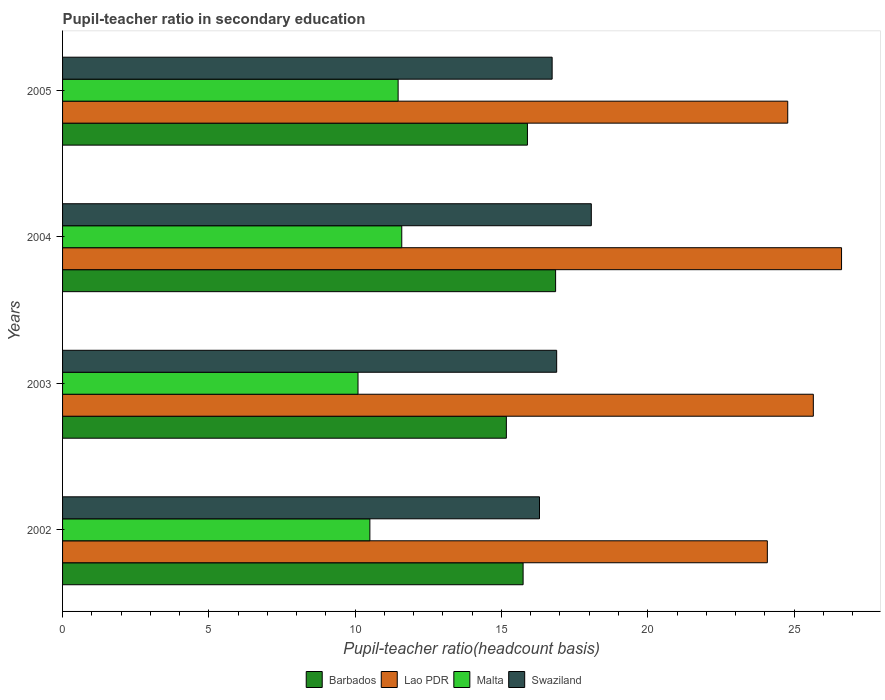Are the number of bars per tick equal to the number of legend labels?
Make the answer very short. Yes. What is the label of the 2nd group of bars from the top?
Provide a short and direct response. 2004. What is the pupil-teacher ratio in secondary education in Lao PDR in 2004?
Give a very brief answer. 26.62. Across all years, what is the maximum pupil-teacher ratio in secondary education in Lao PDR?
Keep it short and to the point. 26.62. Across all years, what is the minimum pupil-teacher ratio in secondary education in Lao PDR?
Keep it short and to the point. 24.09. What is the total pupil-teacher ratio in secondary education in Swaziland in the graph?
Make the answer very short. 67.99. What is the difference between the pupil-teacher ratio in secondary education in Barbados in 2003 and that in 2005?
Make the answer very short. -0.72. What is the difference between the pupil-teacher ratio in secondary education in Barbados in 2005 and the pupil-teacher ratio in secondary education in Malta in 2003?
Make the answer very short. 5.79. What is the average pupil-teacher ratio in secondary education in Lao PDR per year?
Your answer should be compact. 25.29. In the year 2004, what is the difference between the pupil-teacher ratio in secondary education in Barbados and pupil-teacher ratio in secondary education in Malta?
Provide a short and direct response. 5.26. In how many years, is the pupil-teacher ratio in secondary education in Swaziland greater than 20 ?
Make the answer very short. 0. What is the ratio of the pupil-teacher ratio in secondary education in Malta in 2003 to that in 2004?
Provide a short and direct response. 0.87. Is the pupil-teacher ratio in secondary education in Swaziland in 2003 less than that in 2004?
Provide a succinct answer. Yes. Is the difference between the pupil-teacher ratio in secondary education in Barbados in 2004 and 2005 greater than the difference between the pupil-teacher ratio in secondary education in Malta in 2004 and 2005?
Your answer should be compact. Yes. What is the difference between the highest and the second highest pupil-teacher ratio in secondary education in Swaziland?
Give a very brief answer. 1.18. What is the difference between the highest and the lowest pupil-teacher ratio in secondary education in Lao PDR?
Provide a short and direct response. 2.54. Is it the case that in every year, the sum of the pupil-teacher ratio in secondary education in Lao PDR and pupil-teacher ratio in secondary education in Malta is greater than the sum of pupil-teacher ratio in secondary education in Swaziland and pupil-teacher ratio in secondary education in Barbados?
Give a very brief answer. Yes. What does the 4th bar from the top in 2005 represents?
Make the answer very short. Barbados. What does the 1st bar from the bottom in 2004 represents?
Ensure brevity in your answer.  Barbados. Is it the case that in every year, the sum of the pupil-teacher ratio in secondary education in Barbados and pupil-teacher ratio in secondary education in Lao PDR is greater than the pupil-teacher ratio in secondary education in Swaziland?
Your response must be concise. Yes. Are all the bars in the graph horizontal?
Provide a short and direct response. Yes. How many years are there in the graph?
Make the answer very short. 4. Does the graph contain any zero values?
Provide a succinct answer. No. Does the graph contain grids?
Provide a succinct answer. No. How many legend labels are there?
Your answer should be very brief. 4. How are the legend labels stacked?
Provide a short and direct response. Horizontal. What is the title of the graph?
Ensure brevity in your answer.  Pupil-teacher ratio in secondary education. What is the label or title of the X-axis?
Offer a terse response. Pupil-teacher ratio(headcount basis). What is the Pupil-teacher ratio(headcount basis) in Barbados in 2002?
Provide a short and direct response. 15.74. What is the Pupil-teacher ratio(headcount basis) of Lao PDR in 2002?
Your answer should be very brief. 24.09. What is the Pupil-teacher ratio(headcount basis) of Malta in 2002?
Give a very brief answer. 10.5. What is the Pupil-teacher ratio(headcount basis) in Swaziland in 2002?
Provide a short and direct response. 16.3. What is the Pupil-teacher ratio(headcount basis) of Barbados in 2003?
Offer a very short reply. 15.17. What is the Pupil-teacher ratio(headcount basis) of Lao PDR in 2003?
Your answer should be very brief. 25.66. What is the Pupil-teacher ratio(headcount basis) of Malta in 2003?
Ensure brevity in your answer.  10.1. What is the Pupil-teacher ratio(headcount basis) in Swaziland in 2003?
Keep it short and to the point. 16.89. What is the Pupil-teacher ratio(headcount basis) of Barbados in 2004?
Keep it short and to the point. 16.85. What is the Pupil-teacher ratio(headcount basis) in Lao PDR in 2004?
Ensure brevity in your answer.  26.62. What is the Pupil-teacher ratio(headcount basis) of Malta in 2004?
Offer a very short reply. 11.59. What is the Pupil-teacher ratio(headcount basis) of Swaziland in 2004?
Ensure brevity in your answer.  18.07. What is the Pupil-teacher ratio(headcount basis) in Barbados in 2005?
Offer a terse response. 15.89. What is the Pupil-teacher ratio(headcount basis) of Lao PDR in 2005?
Your response must be concise. 24.78. What is the Pupil-teacher ratio(headcount basis) in Malta in 2005?
Keep it short and to the point. 11.47. What is the Pupil-teacher ratio(headcount basis) of Swaziland in 2005?
Make the answer very short. 16.73. Across all years, what is the maximum Pupil-teacher ratio(headcount basis) of Barbados?
Your response must be concise. 16.85. Across all years, what is the maximum Pupil-teacher ratio(headcount basis) in Lao PDR?
Give a very brief answer. 26.62. Across all years, what is the maximum Pupil-teacher ratio(headcount basis) in Malta?
Offer a terse response. 11.59. Across all years, what is the maximum Pupil-teacher ratio(headcount basis) in Swaziland?
Your answer should be compact. 18.07. Across all years, what is the minimum Pupil-teacher ratio(headcount basis) of Barbados?
Provide a short and direct response. 15.17. Across all years, what is the minimum Pupil-teacher ratio(headcount basis) in Lao PDR?
Keep it short and to the point. 24.09. Across all years, what is the minimum Pupil-teacher ratio(headcount basis) of Malta?
Offer a terse response. 10.1. Across all years, what is the minimum Pupil-teacher ratio(headcount basis) in Swaziland?
Make the answer very short. 16.3. What is the total Pupil-teacher ratio(headcount basis) of Barbados in the graph?
Your response must be concise. 63.65. What is the total Pupil-teacher ratio(headcount basis) in Lao PDR in the graph?
Provide a short and direct response. 101.16. What is the total Pupil-teacher ratio(headcount basis) in Malta in the graph?
Offer a very short reply. 43.66. What is the total Pupil-teacher ratio(headcount basis) in Swaziland in the graph?
Keep it short and to the point. 67.99. What is the difference between the Pupil-teacher ratio(headcount basis) in Barbados in 2002 and that in 2003?
Your answer should be very brief. 0.57. What is the difference between the Pupil-teacher ratio(headcount basis) in Lao PDR in 2002 and that in 2003?
Keep it short and to the point. -1.57. What is the difference between the Pupil-teacher ratio(headcount basis) of Malta in 2002 and that in 2003?
Offer a very short reply. 0.41. What is the difference between the Pupil-teacher ratio(headcount basis) of Swaziland in 2002 and that in 2003?
Your response must be concise. -0.59. What is the difference between the Pupil-teacher ratio(headcount basis) in Barbados in 2002 and that in 2004?
Offer a very short reply. -1.11. What is the difference between the Pupil-teacher ratio(headcount basis) in Lao PDR in 2002 and that in 2004?
Provide a succinct answer. -2.54. What is the difference between the Pupil-teacher ratio(headcount basis) of Malta in 2002 and that in 2004?
Give a very brief answer. -1.09. What is the difference between the Pupil-teacher ratio(headcount basis) of Swaziland in 2002 and that in 2004?
Your response must be concise. -1.77. What is the difference between the Pupil-teacher ratio(headcount basis) in Barbados in 2002 and that in 2005?
Ensure brevity in your answer.  -0.15. What is the difference between the Pupil-teacher ratio(headcount basis) in Lao PDR in 2002 and that in 2005?
Provide a succinct answer. -0.7. What is the difference between the Pupil-teacher ratio(headcount basis) in Malta in 2002 and that in 2005?
Ensure brevity in your answer.  -0.97. What is the difference between the Pupil-teacher ratio(headcount basis) of Swaziland in 2002 and that in 2005?
Ensure brevity in your answer.  -0.43. What is the difference between the Pupil-teacher ratio(headcount basis) in Barbados in 2003 and that in 2004?
Provide a short and direct response. -1.68. What is the difference between the Pupil-teacher ratio(headcount basis) of Lao PDR in 2003 and that in 2004?
Ensure brevity in your answer.  -0.96. What is the difference between the Pupil-teacher ratio(headcount basis) of Malta in 2003 and that in 2004?
Keep it short and to the point. -1.5. What is the difference between the Pupil-teacher ratio(headcount basis) of Swaziland in 2003 and that in 2004?
Keep it short and to the point. -1.18. What is the difference between the Pupil-teacher ratio(headcount basis) of Barbados in 2003 and that in 2005?
Ensure brevity in your answer.  -0.72. What is the difference between the Pupil-teacher ratio(headcount basis) of Lao PDR in 2003 and that in 2005?
Give a very brief answer. 0.88. What is the difference between the Pupil-teacher ratio(headcount basis) in Malta in 2003 and that in 2005?
Keep it short and to the point. -1.37. What is the difference between the Pupil-teacher ratio(headcount basis) in Swaziland in 2003 and that in 2005?
Provide a succinct answer. 0.15. What is the difference between the Pupil-teacher ratio(headcount basis) of Barbados in 2004 and that in 2005?
Your answer should be very brief. 0.96. What is the difference between the Pupil-teacher ratio(headcount basis) in Lao PDR in 2004 and that in 2005?
Your answer should be very brief. 1.84. What is the difference between the Pupil-teacher ratio(headcount basis) of Malta in 2004 and that in 2005?
Keep it short and to the point. 0.12. What is the difference between the Pupil-teacher ratio(headcount basis) in Swaziland in 2004 and that in 2005?
Give a very brief answer. 1.34. What is the difference between the Pupil-teacher ratio(headcount basis) of Barbados in 2002 and the Pupil-teacher ratio(headcount basis) of Lao PDR in 2003?
Your answer should be compact. -9.92. What is the difference between the Pupil-teacher ratio(headcount basis) of Barbados in 2002 and the Pupil-teacher ratio(headcount basis) of Malta in 2003?
Offer a very short reply. 5.64. What is the difference between the Pupil-teacher ratio(headcount basis) in Barbados in 2002 and the Pupil-teacher ratio(headcount basis) in Swaziland in 2003?
Your answer should be compact. -1.15. What is the difference between the Pupil-teacher ratio(headcount basis) in Lao PDR in 2002 and the Pupil-teacher ratio(headcount basis) in Malta in 2003?
Your response must be concise. 13.99. What is the difference between the Pupil-teacher ratio(headcount basis) of Lao PDR in 2002 and the Pupil-teacher ratio(headcount basis) of Swaziland in 2003?
Keep it short and to the point. 7.2. What is the difference between the Pupil-teacher ratio(headcount basis) in Malta in 2002 and the Pupil-teacher ratio(headcount basis) in Swaziland in 2003?
Give a very brief answer. -6.38. What is the difference between the Pupil-teacher ratio(headcount basis) in Barbados in 2002 and the Pupil-teacher ratio(headcount basis) in Lao PDR in 2004?
Provide a succinct answer. -10.88. What is the difference between the Pupil-teacher ratio(headcount basis) in Barbados in 2002 and the Pupil-teacher ratio(headcount basis) in Malta in 2004?
Give a very brief answer. 4.15. What is the difference between the Pupil-teacher ratio(headcount basis) in Barbados in 2002 and the Pupil-teacher ratio(headcount basis) in Swaziland in 2004?
Your response must be concise. -2.33. What is the difference between the Pupil-teacher ratio(headcount basis) in Lao PDR in 2002 and the Pupil-teacher ratio(headcount basis) in Malta in 2004?
Provide a short and direct response. 12.49. What is the difference between the Pupil-teacher ratio(headcount basis) of Lao PDR in 2002 and the Pupil-teacher ratio(headcount basis) of Swaziland in 2004?
Offer a very short reply. 6.02. What is the difference between the Pupil-teacher ratio(headcount basis) in Malta in 2002 and the Pupil-teacher ratio(headcount basis) in Swaziland in 2004?
Give a very brief answer. -7.57. What is the difference between the Pupil-teacher ratio(headcount basis) in Barbados in 2002 and the Pupil-teacher ratio(headcount basis) in Lao PDR in 2005?
Ensure brevity in your answer.  -9.04. What is the difference between the Pupil-teacher ratio(headcount basis) in Barbados in 2002 and the Pupil-teacher ratio(headcount basis) in Malta in 2005?
Your answer should be very brief. 4.27. What is the difference between the Pupil-teacher ratio(headcount basis) of Barbados in 2002 and the Pupil-teacher ratio(headcount basis) of Swaziland in 2005?
Offer a very short reply. -0.99. What is the difference between the Pupil-teacher ratio(headcount basis) in Lao PDR in 2002 and the Pupil-teacher ratio(headcount basis) in Malta in 2005?
Your answer should be compact. 12.62. What is the difference between the Pupil-teacher ratio(headcount basis) in Lao PDR in 2002 and the Pupil-teacher ratio(headcount basis) in Swaziland in 2005?
Offer a terse response. 7.36. What is the difference between the Pupil-teacher ratio(headcount basis) in Malta in 2002 and the Pupil-teacher ratio(headcount basis) in Swaziland in 2005?
Your answer should be very brief. -6.23. What is the difference between the Pupil-teacher ratio(headcount basis) in Barbados in 2003 and the Pupil-teacher ratio(headcount basis) in Lao PDR in 2004?
Your answer should be compact. -11.46. What is the difference between the Pupil-teacher ratio(headcount basis) of Barbados in 2003 and the Pupil-teacher ratio(headcount basis) of Malta in 2004?
Offer a terse response. 3.57. What is the difference between the Pupil-teacher ratio(headcount basis) of Barbados in 2003 and the Pupil-teacher ratio(headcount basis) of Swaziland in 2004?
Give a very brief answer. -2.9. What is the difference between the Pupil-teacher ratio(headcount basis) in Lao PDR in 2003 and the Pupil-teacher ratio(headcount basis) in Malta in 2004?
Your answer should be very brief. 14.07. What is the difference between the Pupil-teacher ratio(headcount basis) in Lao PDR in 2003 and the Pupil-teacher ratio(headcount basis) in Swaziland in 2004?
Give a very brief answer. 7.59. What is the difference between the Pupil-teacher ratio(headcount basis) in Malta in 2003 and the Pupil-teacher ratio(headcount basis) in Swaziland in 2004?
Provide a short and direct response. -7.97. What is the difference between the Pupil-teacher ratio(headcount basis) of Barbados in 2003 and the Pupil-teacher ratio(headcount basis) of Lao PDR in 2005?
Your answer should be very brief. -9.62. What is the difference between the Pupil-teacher ratio(headcount basis) in Barbados in 2003 and the Pupil-teacher ratio(headcount basis) in Malta in 2005?
Give a very brief answer. 3.7. What is the difference between the Pupil-teacher ratio(headcount basis) in Barbados in 2003 and the Pupil-teacher ratio(headcount basis) in Swaziland in 2005?
Offer a very short reply. -1.56. What is the difference between the Pupil-teacher ratio(headcount basis) in Lao PDR in 2003 and the Pupil-teacher ratio(headcount basis) in Malta in 2005?
Ensure brevity in your answer.  14.19. What is the difference between the Pupil-teacher ratio(headcount basis) in Lao PDR in 2003 and the Pupil-teacher ratio(headcount basis) in Swaziland in 2005?
Your answer should be compact. 8.93. What is the difference between the Pupil-teacher ratio(headcount basis) in Malta in 2003 and the Pupil-teacher ratio(headcount basis) in Swaziland in 2005?
Provide a succinct answer. -6.64. What is the difference between the Pupil-teacher ratio(headcount basis) of Barbados in 2004 and the Pupil-teacher ratio(headcount basis) of Lao PDR in 2005?
Keep it short and to the point. -7.93. What is the difference between the Pupil-teacher ratio(headcount basis) in Barbados in 2004 and the Pupil-teacher ratio(headcount basis) in Malta in 2005?
Your answer should be very brief. 5.38. What is the difference between the Pupil-teacher ratio(headcount basis) of Barbados in 2004 and the Pupil-teacher ratio(headcount basis) of Swaziland in 2005?
Provide a short and direct response. 0.12. What is the difference between the Pupil-teacher ratio(headcount basis) of Lao PDR in 2004 and the Pupil-teacher ratio(headcount basis) of Malta in 2005?
Ensure brevity in your answer.  15.16. What is the difference between the Pupil-teacher ratio(headcount basis) of Lao PDR in 2004 and the Pupil-teacher ratio(headcount basis) of Swaziland in 2005?
Your answer should be very brief. 9.89. What is the difference between the Pupil-teacher ratio(headcount basis) in Malta in 2004 and the Pupil-teacher ratio(headcount basis) in Swaziland in 2005?
Keep it short and to the point. -5.14. What is the average Pupil-teacher ratio(headcount basis) of Barbados per year?
Offer a very short reply. 15.91. What is the average Pupil-teacher ratio(headcount basis) in Lao PDR per year?
Give a very brief answer. 25.29. What is the average Pupil-teacher ratio(headcount basis) in Malta per year?
Your response must be concise. 10.92. What is the average Pupil-teacher ratio(headcount basis) of Swaziland per year?
Your response must be concise. 17. In the year 2002, what is the difference between the Pupil-teacher ratio(headcount basis) of Barbados and Pupil-teacher ratio(headcount basis) of Lao PDR?
Ensure brevity in your answer.  -8.35. In the year 2002, what is the difference between the Pupil-teacher ratio(headcount basis) in Barbados and Pupil-teacher ratio(headcount basis) in Malta?
Your answer should be compact. 5.24. In the year 2002, what is the difference between the Pupil-teacher ratio(headcount basis) of Barbados and Pupil-teacher ratio(headcount basis) of Swaziland?
Provide a succinct answer. -0.56. In the year 2002, what is the difference between the Pupil-teacher ratio(headcount basis) in Lao PDR and Pupil-teacher ratio(headcount basis) in Malta?
Offer a very short reply. 13.58. In the year 2002, what is the difference between the Pupil-teacher ratio(headcount basis) of Lao PDR and Pupil-teacher ratio(headcount basis) of Swaziland?
Ensure brevity in your answer.  7.79. In the year 2002, what is the difference between the Pupil-teacher ratio(headcount basis) in Malta and Pupil-teacher ratio(headcount basis) in Swaziland?
Your answer should be very brief. -5.8. In the year 2003, what is the difference between the Pupil-teacher ratio(headcount basis) of Barbados and Pupil-teacher ratio(headcount basis) of Lao PDR?
Make the answer very short. -10.49. In the year 2003, what is the difference between the Pupil-teacher ratio(headcount basis) in Barbados and Pupil-teacher ratio(headcount basis) in Malta?
Your answer should be very brief. 5.07. In the year 2003, what is the difference between the Pupil-teacher ratio(headcount basis) of Barbados and Pupil-teacher ratio(headcount basis) of Swaziland?
Provide a short and direct response. -1.72. In the year 2003, what is the difference between the Pupil-teacher ratio(headcount basis) in Lao PDR and Pupil-teacher ratio(headcount basis) in Malta?
Your answer should be compact. 15.56. In the year 2003, what is the difference between the Pupil-teacher ratio(headcount basis) of Lao PDR and Pupil-teacher ratio(headcount basis) of Swaziland?
Provide a succinct answer. 8.77. In the year 2003, what is the difference between the Pupil-teacher ratio(headcount basis) in Malta and Pupil-teacher ratio(headcount basis) in Swaziland?
Your answer should be compact. -6.79. In the year 2004, what is the difference between the Pupil-teacher ratio(headcount basis) of Barbados and Pupil-teacher ratio(headcount basis) of Lao PDR?
Your response must be concise. -9.77. In the year 2004, what is the difference between the Pupil-teacher ratio(headcount basis) of Barbados and Pupil-teacher ratio(headcount basis) of Malta?
Keep it short and to the point. 5.26. In the year 2004, what is the difference between the Pupil-teacher ratio(headcount basis) in Barbados and Pupil-teacher ratio(headcount basis) in Swaziland?
Offer a very short reply. -1.22. In the year 2004, what is the difference between the Pupil-teacher ratio(headcount basis) of Lao PDR and Pupil-teacher ratio(headcount basis) of Malta?
Provide a short and direct response. 15.03. In the year 2004, what is the difference between the Pupil-teacher ratio(headcount basis) in Lao PDR and Pupil-teacher ratio(headcount basis) in Swaziland?
Make the answer very short. 8.55. In the year 2004, what is the difference between the Pupil-teacher ratio(headcount basis) of Malta and Pupil-teacher ratio(headcount basis) of Swaziland?
Offer a very short reply. -6.48. In the year 2005, what is the difference between the Pupil-teacher ratio(headcount basis) in Barbados and Pupil-teacher ratio(headcount basis) in Lao PDR?
Offer a terse response. -8.9. In the year 2005, what is the difference between the Pupil-teacher ratio(headcount basis) of Barbados and Pupil-teacher ratio(headcount basis) of Malta?
Your response must be concise. 4.42. In the year 2005, what is the difference between the Pupil-teacher ratio(headcount basis) of Barbados and Pupil-teacher ratio(headcount basis) of Swaziland?
Your answer should be compact. -0.84. In the year 2005, what is the difference between the Pupil-teacher ratio(headcount basis) of Lao PDR and Pupil-teacher ratio(headcount basis) of Malta?
Provide a short and direct response. 13.32. In the year 2005, what is the difference between the Pupil-teacher ratio(headcount basis) of Lao PDR and Pupil-teacher ratio(headcount basis) of Swaziland?
Provide a succinct answer. 8.05. In the year 2005, what is the difference between the Pupil-teacher ratio(headcount basis) in Malta and Pupil-teacher ratio(headcount basis) in Swaziland?
Provide a short and direct response. -5.26. What is the ratio of the Pupil-teacher ratio(headcount basis) of Barbados in 2002 to that in 2003?
Offer a very short reply. 1.04. What is the ratio of the Pupil-teacher ratio(headcount basis) in Lao PDR in 2002 to that in 2003?
Ensure brevity in your answer.  0.94. What is the ratio of the Pupil-teacher ratio(headcount basis) of Malta in 2002 to that in 2003?
Provide a succinct answer. 1.04. What is the ratio of the Pupil-teacher ratio(headcount basis) of Swaziland in 2002 to that in 2003?
Your answer should be very brief. 0.97. What is the ratio of the Pupil-teacher ratio(headcount basis) in Barbados in 2002 to that in 2004?
Make the answer very short. 0.93. What is the ratio of the Pupil-teacher ratio(headcount basis) in Lao PDR in 2002 to that in 2004?
Provide a short and direct response. 0.9. What is the ratio of the Pupil-teacher ratio(headcount basis) of Malta in 2002 to that in 2004?
Provide a succinct answer. 0.91. What is the ratio of the Pupil-teacher ratio(headcount basis) of Swaziland in 2002 to that in 2004?
Your answer should be very brief. 0.9. What is the ratio of the Pupil-teacher ratio(headcount basis) in Barbados in 2002 to that in 2005?
Offer a terse response. 0.99. What is the ratio of the Pupil-teacher ratio(headcount basis) in Lao PDR in 2002 to that in 2005?
Give a very brief answer. 0.97. What is the ratio of the Pupil-teacher ratio(headcount basis) in Malta in 2002 to that in 2005?
Offer a very short reply. 0.92. What is the ratio of the Pupil-teacher ratio(headcount basis) of Swaziland in 2002 to that in 2005?
Provide a short and direct response. 0.97. What is the ratio of the Pupil-teacher ratio(headcount basis) of Barbados in 2003 to that in 2004?
Give a very brief answer. 0.9. What is the ratio of the Pupil-teacher ratio(headcount basis) in Lao PDR in 2003 to that in 2004?
Make the answer very short. 0.96. What is the ratio of the Pupil-teacher ratio(headcount basis) in Malta in 2003 to that in 2004?
Your answer should be compact. 0.87. What is the ratio of the Pupil-teacher ratio(headcount basis) in Swaziland in 2003 to that in 2004?
Your response must be concise. 0.93. What is the ratio of the Pupil-teacher ratio(headcount basis) in Barbados in 2003 to that in 2005?
Keep it short and to the point. 0.95. What is the ratio of the Pupil-teacher ratio(headcount basis) of Lao PDR in 2003 to that in 2005?
Provide a short and direct response. 1.04. What is the ratio of the Pupil-teacher ratio(headcount basis) in Malta in 2003 to that in 2005?
Provide a succinct answer. 0.88. What is the ratio of the Pupil-teacher ratio(headcount basis) in Swaziland in 2003 to that in 2005?
Your answer should be compact. 1.01. What is the ratio of the Pupil-teacher ratio(headcount basis) of Barbados in 2004 to that in 2005?
Your answer should be very brief. 1.06. What is the ratio of the Pupil-teacher ratio(headcount basis) in Lao PDR in 2004 to that in 2005?
Your answer should be very brief. 1.07. What is the ratio of the Pupil-teacher ratio(headcount basis) of Malta in 2004 to that in 2005?
Provide a succinct answer. 1.01. What is the ratio of the Pupil-teacher ratio(headcount basis) of Swaziland in 2004 to that in 2005?
Offer a terse response. 1.08. What is the difference between the highest and the second highest Pupil-teacher ratio(headcount basis) in Barbados?
Your answer should be very brief. 0.96. What is the difference between the highest and the second highest Pupil-teacher ratio(headcount basis) of Lao PDR?
Ensure brevity in your answer.  0.96. What is the difference between the highest and the second highest Pupil-teacher ratio(headcount basis) in Malta?
Provide a short and direct response. 0.12. What is the difference between the highest and the second highest Pupil-teacher ratio(headcount basis) of Swaziland?
Offer a terse response. 1.18. What is the difference between the highest and the lowest Pupil-teacher ratio(headcount basis) in Barbados?
Offer a terse response. 1.68. What is the difference between the highest and the lowest Pupil-teacher ratio(headcount basis) of Lao PDR?
Provide a succinct answer. 2.54. What is the difference between the highest and the lowest Pupil-teacher ratio(headcount basis) of Malta?
Give a very brief answer. 1.5. What is the difference between the highest and the lowest Pupil-teacher ratio(headcount basis) of Swaziland?
Offer a terse response. 1.77. 